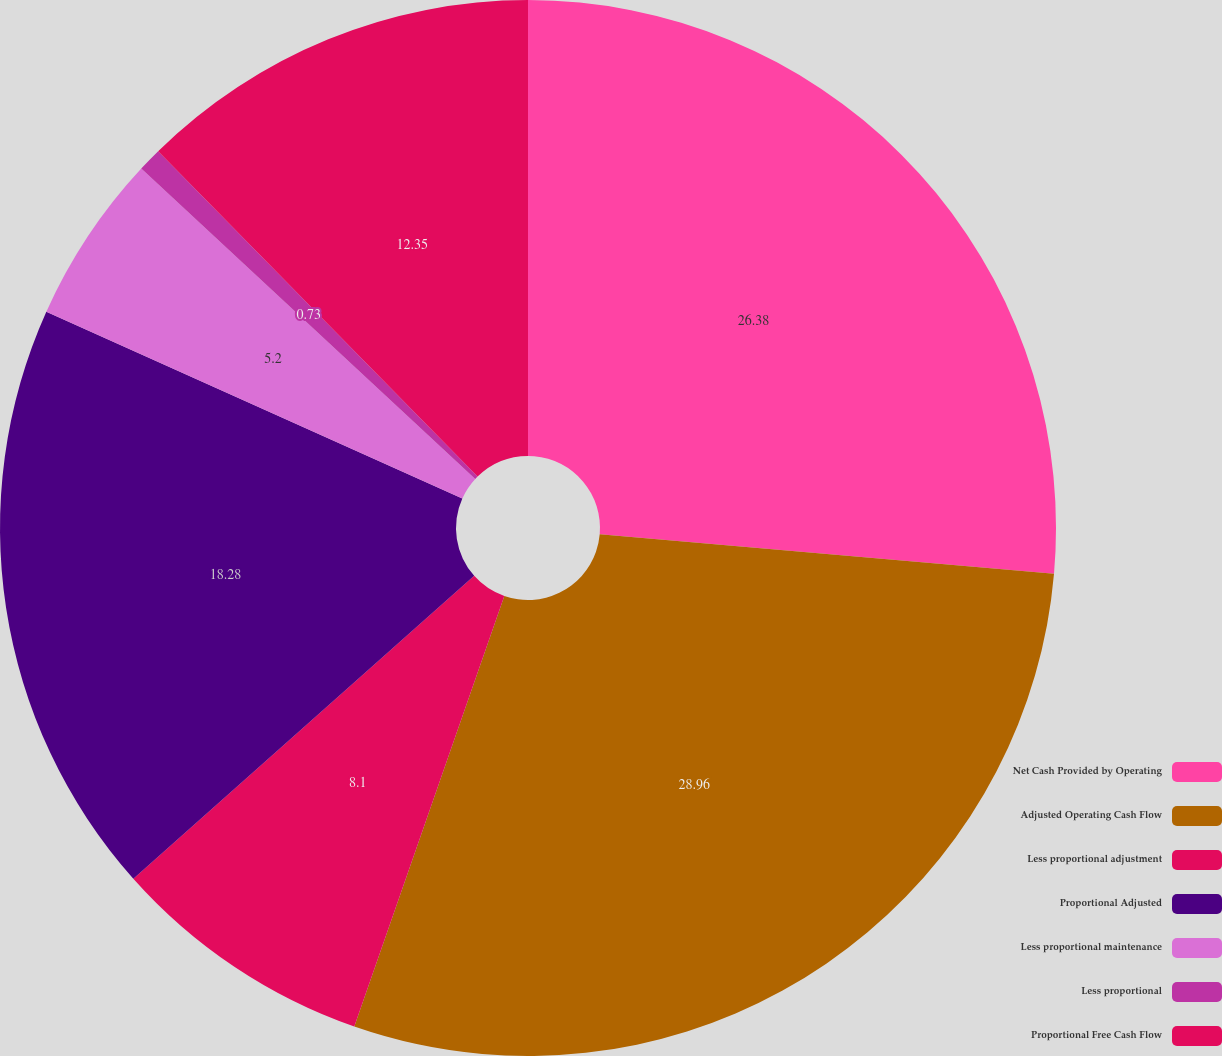<chart> <loc_0><loc_0><loc_500><loc_500><pie_chart><fcel>Net Cash Provided by Operating<fcel>Adjusted Operating Cash Flow<fcel>Less proportional adjustment<fcel>Proportional Adjusted<fcel>Less proportional maintenance<fcel>Less proportional<fcel>Proportional Free Cash Flow<nl><fcel>26.38%<fcel>28.95%<fcel>8.1%<fcel>18.28%<fcel>5.2%<fcel>0.73%<fcel>12.35%<nl></chart> 